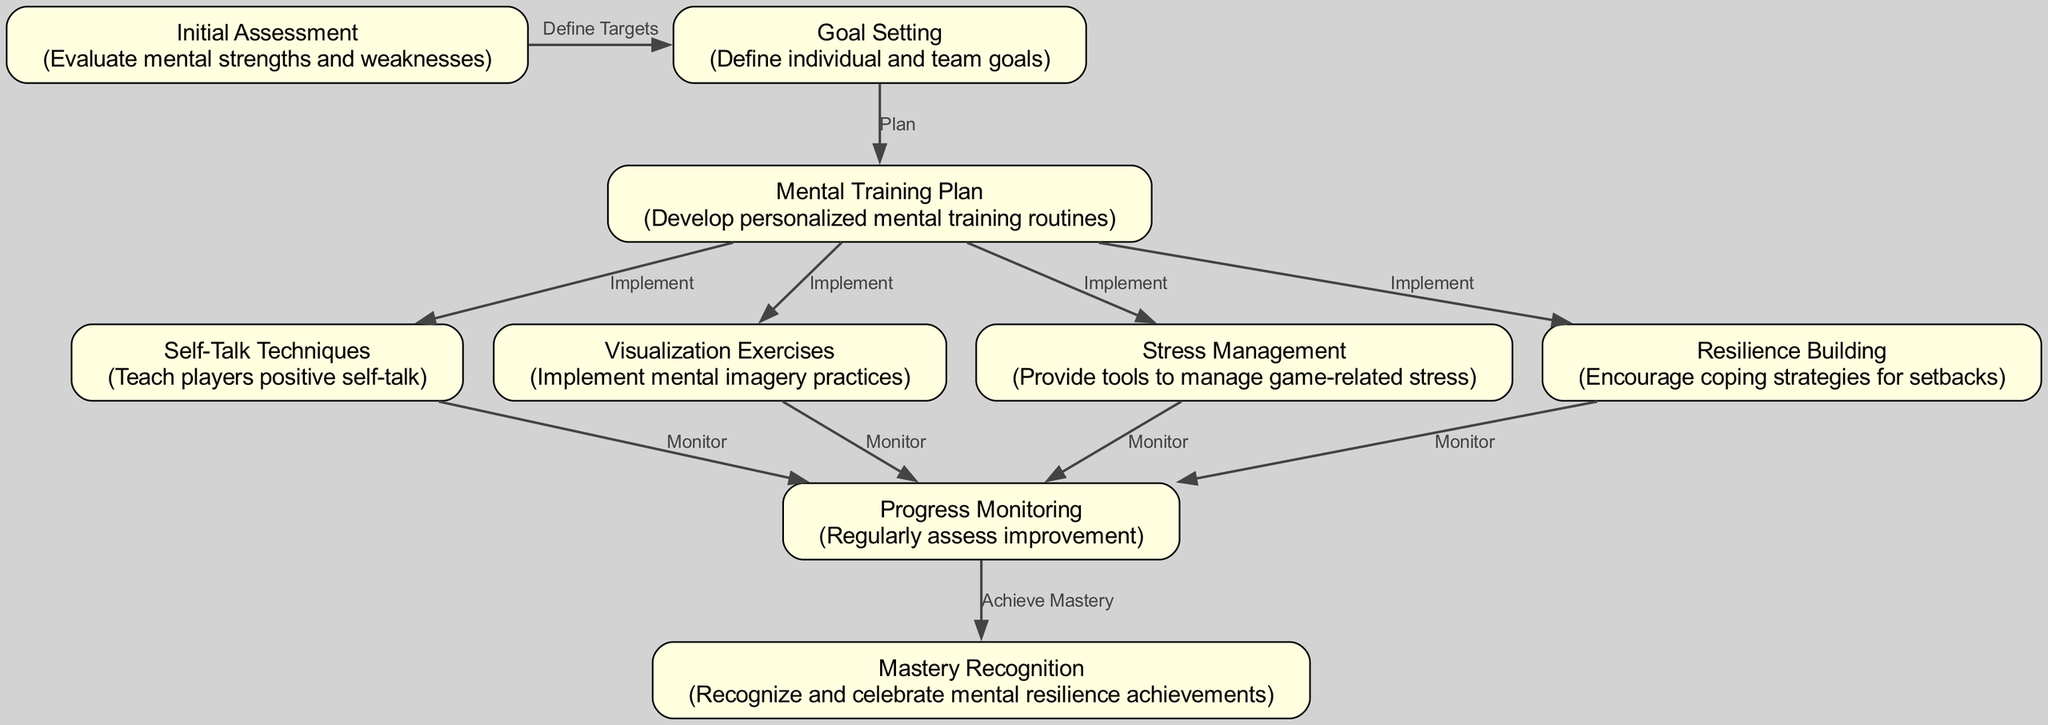What is the first phase in the diagram? The diagram lists "Initial Assessment" as the first phase, which is the starting point for the development of mental resilience.
Answer: Initial Assessment How many nodes are in the diagram? Counting all unique nodes listed in the diagram, there are nine nodes representing different phases of the mental resilience development process.
Answer: 9 What follows after "Goal Setting"? The flow from "Goal Setting" leads to "Mental Training Plan," making it the next phase after establishing goals.
Answer: Mental Training Plan Which phase involves teaching players positive self-talk? In the diagram, the phase that specifically deals with teaching players positive self-talk is labeled "Self-Talk Techniques."
Answer: Self-Talk Techniques What is the final phase in the process? The last phase mentioned in the diagram is "Mastery Recognition," which indicates the culmination of the mental resilience training efforts.
Answer: Mastery Recognition How many different techniques are implemented in the "Mental Training Plan"? The "Mental Training Plan" leads to four distinct techniques or phases being implemented: self-talk, visualization exercises, stress management, and resilience building.
Answer: 4 Which nodes are directly monitored? The nodes that are monitored according to the diagram are "Self-Talk Techniques," "Visualization Exercises," "Stress Management," and "Resilience Building."
Answer: 4 What is the relationship between "Progress Monitoring" and "Mastery Recognition"? The relationship is that "Progress Monitoring" leads to "Mastery Recognition," indicating that monitoring improvement is essential for recognizing mastery achievements.
Answer: Achieve Mastery What label connects "Initial Assessment" to "Goal Setting"? The connection label between "Initial Assessment" and "Goal Setting" is "Define Targets," which suggests the purpose of the assessment phase.
Answer: Define Targets 